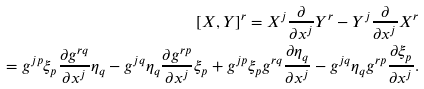<formula> <loc_0><loc_0><loc_500><loc_500>[ X , Y ] ^ { r } = X ^ { j } \frac { \partial } { \partial x ^ { j } } Y ^ { r } - Y ^ { j } \frac { \partial } { \partial x ^ { j } } X ^ { r } \\ = g ^ { j p } \xi _ { p } \frac { \partial g ^ { r q } } { \partial x ^ { j } } \eta _ { q } - g ^ { j q } \eta _ { q } \frac { \partial g ^ { r p } } { \partial x ^ { j } } \xi _ { p } + g ^ { j p } \xi _ { p } g ^ { r q } \frac { \partial \eta _ { q } } { \partial x ^ { j } } - g ^ { j q } \eta _ { q } g ^ { r p } \frac { \partial \xi _ { p } } { \partial x ^ { j } } .</formula> 